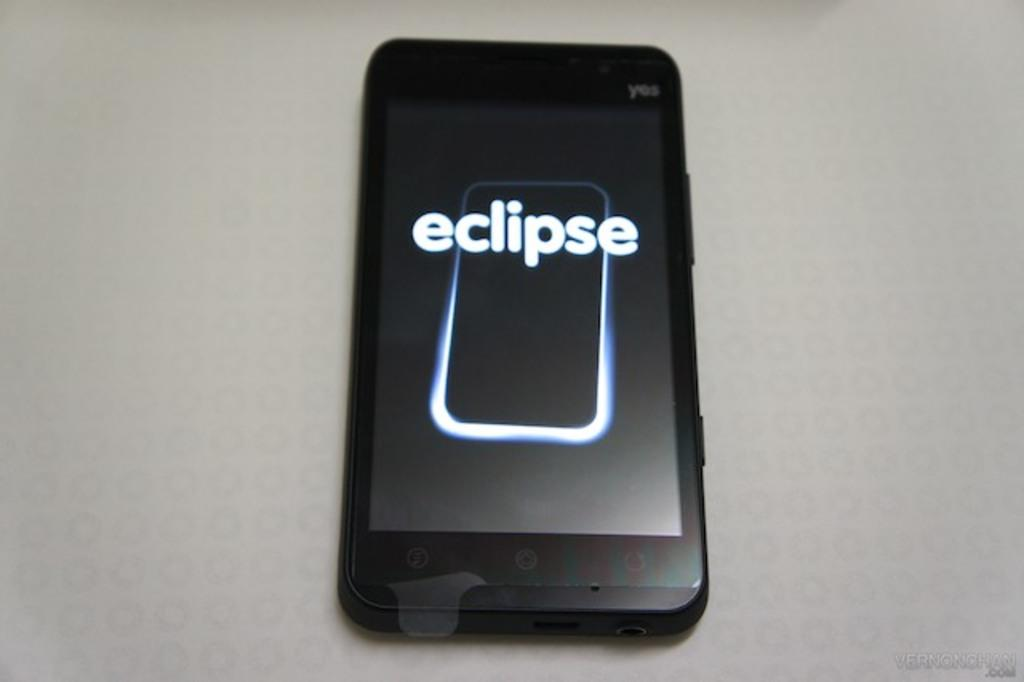<image>
Provide a brief description of the given image. A black iPhone laying on a grey surface with the screen on and with the word eclipse on the screen. 